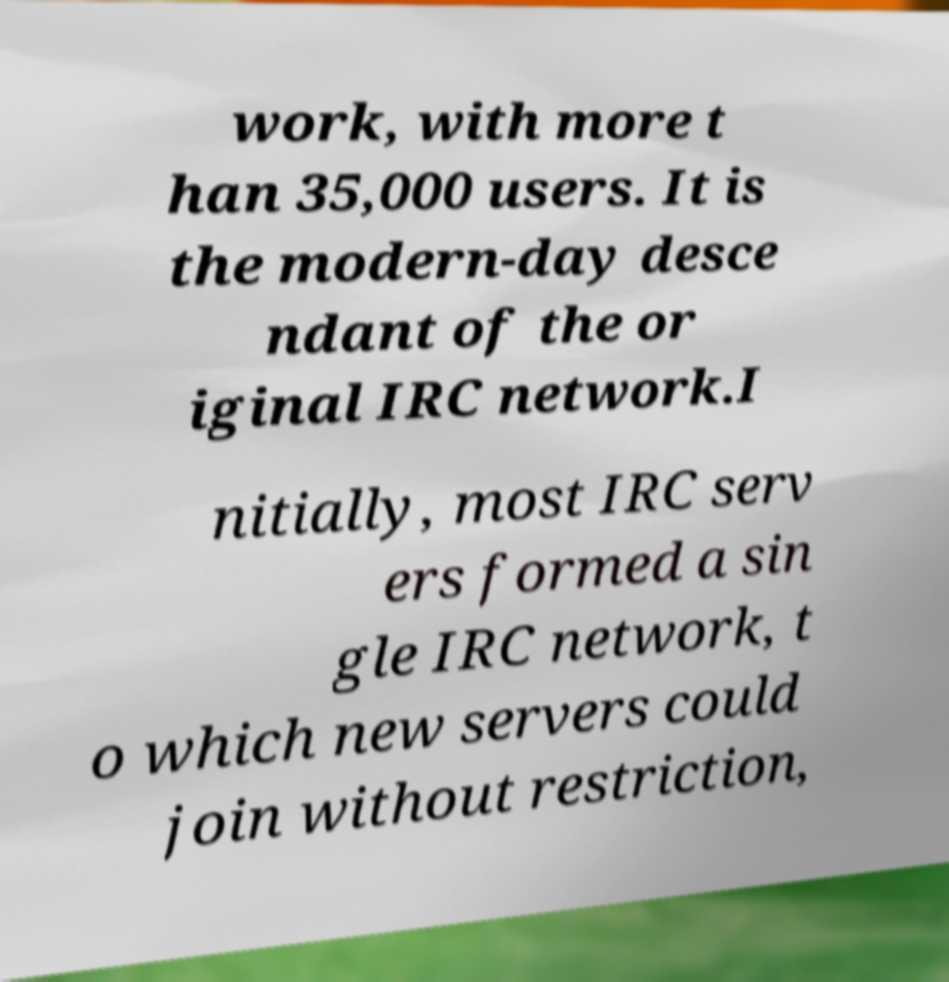Could you assist in decoding the text presented in this image and type it out clearly? work, with more t han 35,000 users. It is the modern-day desce ndant of the or iginal IRC network.I nitially, most IRC serv ers formed a sin gle IRC network, t o which new servers could join without restriction, 